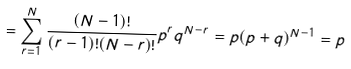Convert formula to latex. <formula><loc_0><loc_0><loc_500><loc_500>= \sum _ { r = 1 } ^ { N } \frac { ( N - 1 ) ! } { ( r - 1 ) ! ( N - r ) ! } p ^ { r } q ^ { N - r } = p ( p + q ) ^ { N - 1 } = p</formula> 